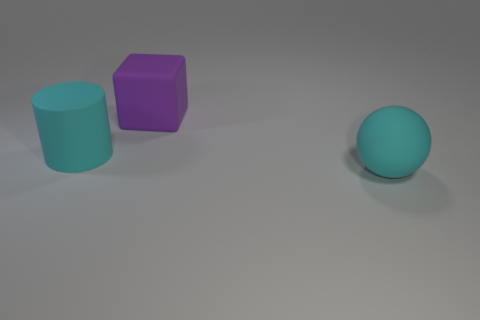Add 2 tiny red things. How many objects exist? 5 Subtract all blocks. How many objects are left? 2 Subtract all purple matte blocks. Subtract all big cyan rubber cylinders. How many objects are left? 1 Add 2 cylinders. How many cylinders are left? 3 Add 2 big brown rubber things. How many big brown rubber things exist? 2 Subtract 0 brown cylinders. How many objects are left? 3 